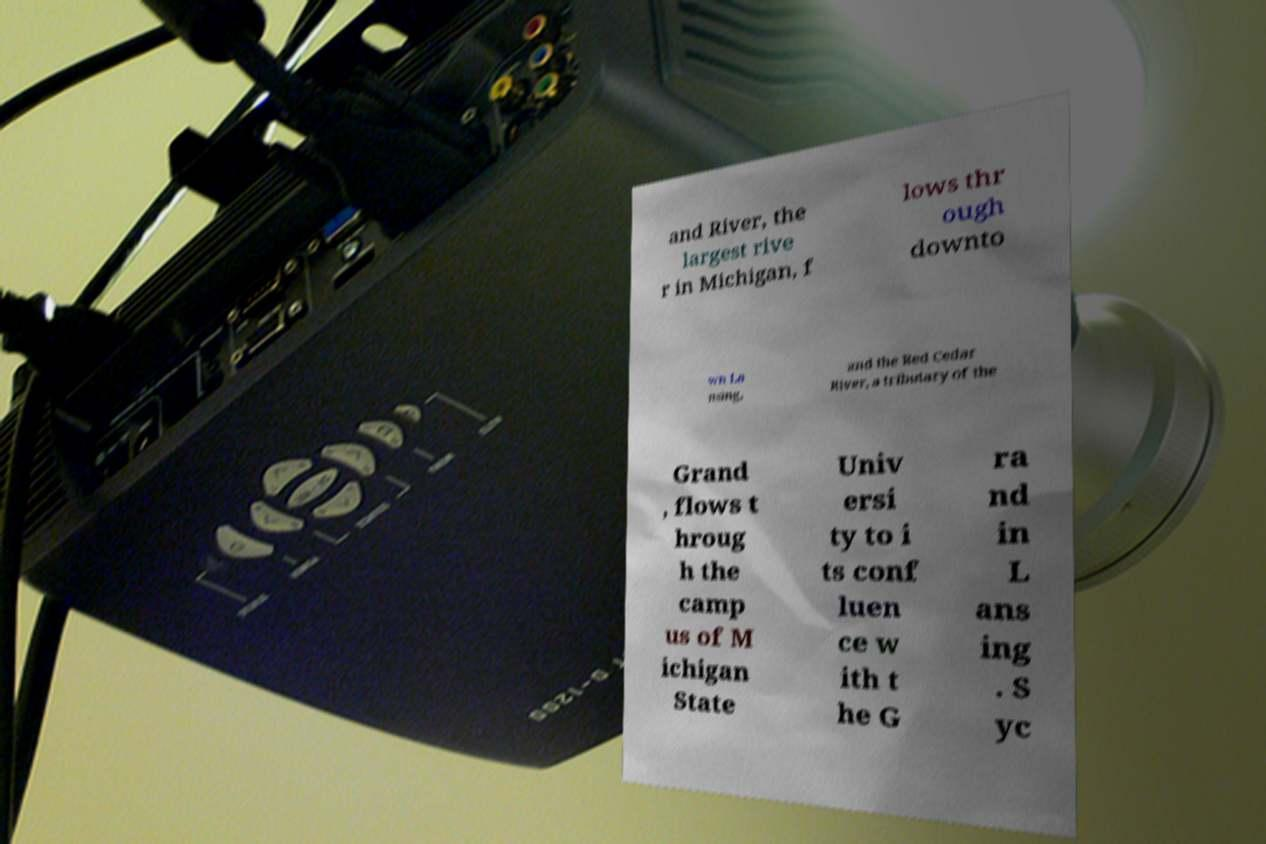Can you accurately transcribe the text from the provided image for me? and River, the largest rive r in Michigan, f lows thr ough downto wn La nsing, and the Red Cedar River, a tributary of the Grand , flows t hroug h the camp us of M ichigan State Univ ersi ty to i ts conf luen ce w ith t he G ra nd in L ans ing . S yc 